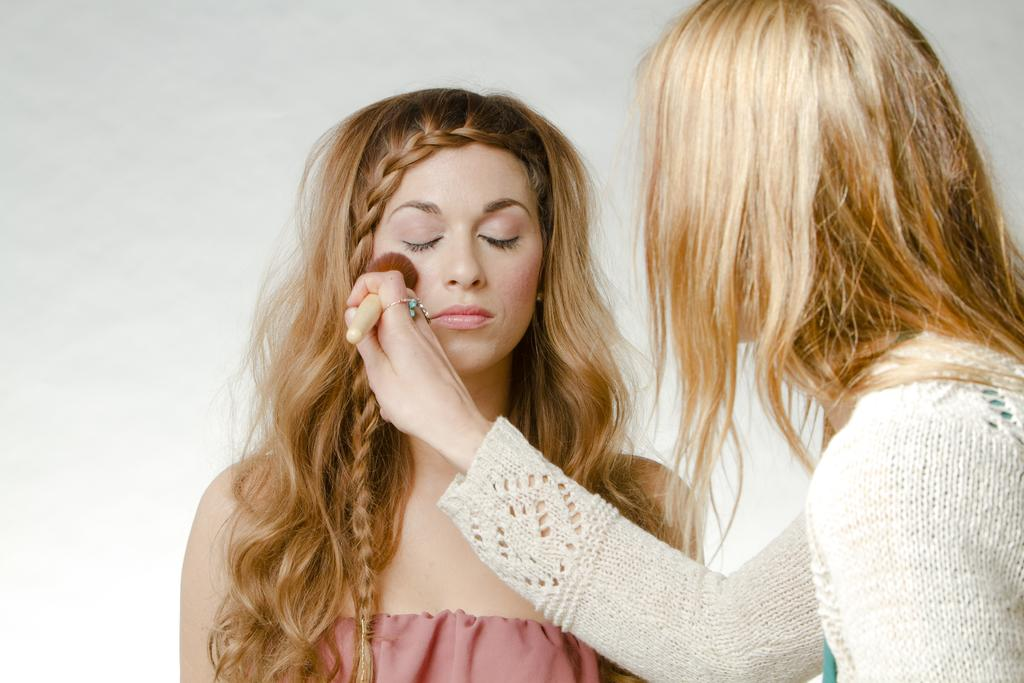How many people are in the image? There are two women in the image. What is one of the women holding in her hand? One of the women is holding a brush in her hand. What color is the background of the image? The background of the image is white. What type of government is depicted in the image? There is no depiction of a government in the image; it features two women and a brush. What material is the quill made of in the image? There is no quill present in the image. 